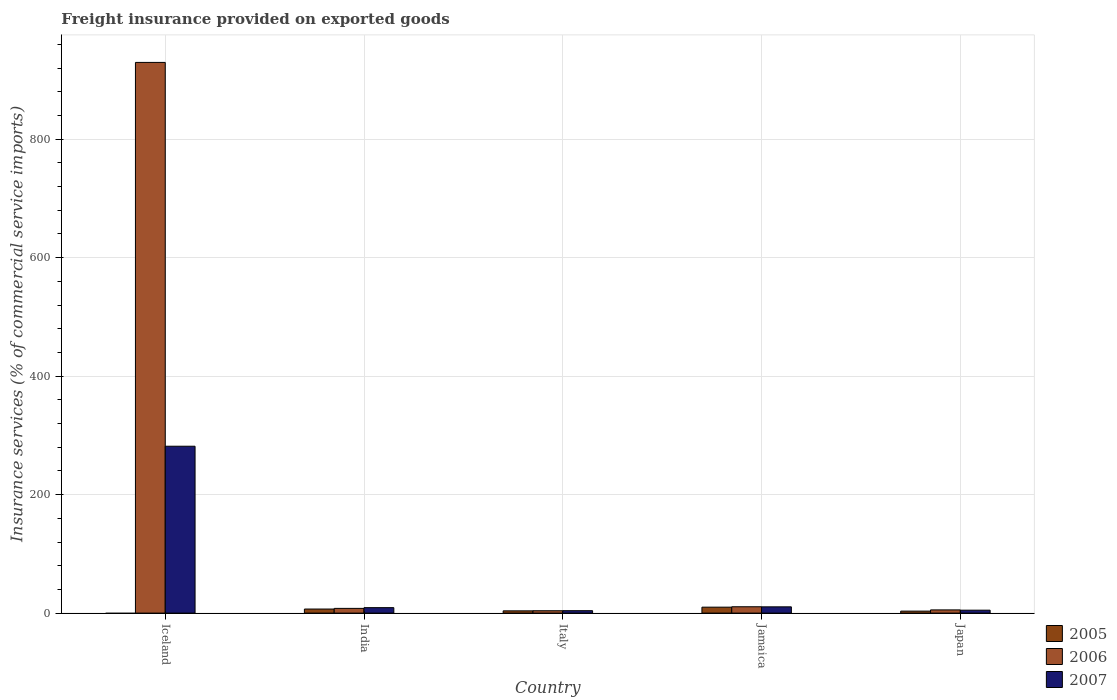How many different coloured bars are there?
Offer a terse response. 3. How many bars are there on the 1st tick from the left?
Offer a terse response. 2. In how many cases, is the number of bars for a given country not equal to the number of legend labels?
Provide a succinct answer. 1. What is the freight insurance provided on exported goods in 2005 in India?
Provide a succinct answer. 6.85. Across all countries, what is the maximum freight insurance provided on exported goods in 2006?
Make the answer very short. 929.6. Across all countries, what is the minimum freight insurance provided on exported goods in 2006?
Provide a short and direct response. 3.97. In which country was the freight insurance provided on exported goods in 2005 maximum?
Make the answer very short. Jamaica. What is the total freight insurance provided on exported goods in 2007 in the graph?
Your answer should be very brief. 310.44. What is the difference between the freight insurance provided on exported goods in 2007 in Italy and that in Japan?
Your answer should be compact. -0.85. What is the difference between the freight insurance provided on exported goods in 2006 in Jamaica and the freight insurance provided on exported goods in 2007 in Japan?
Offer a terse response. 5.79. What is the average freight insurance provided on exported goods in 2007 per country?
Offer a terse response. 62.09. What is the difference between the freight insurance provided on exported goods of/in 2007 and freight insurance provided on exported goods of/in 2005 in Japan?
Give a very brief answer. 1.59. What is the ratio of the freight insurance provided on exported goods in 2007 in India to that in Japan?
Your response must be concise. 1.87. Is the freight insurance provided on exported goods in 2006 in Iceland less than that in India?
Your answer should be compact. No. What is the difference between the highest and the second highest freight insurance provided on exported goods in 2007?
Provide a short and direct response. 271.12. What is the difference between the highest and the lowest freight insurance provided on exported goods in 2006?
Provide a succinct answer. 925.62. In how many countries, is the freight insurance provided on exported goods in 2006 greater than the average freight insurance provided on exported goods in 2006 taken over all countries?
Your answer should be very brief. 1. Is it the case that in every country, the sum of the freight insurance provided on exported goods in 2006 and freight insurance provided on exported goods in 2007 is greater than the freight insurance provided on exported goods in 2005?
Ensure brevity in your answer.  Yes. Are all the bars in the graph horizontal?
Make the answer very short. No. Are the values on the major ticks of Y-axis written in scientific E-notation?
Your answer should be very brief. No. What is the title of the graph?
Offer a terse response. Freight insurance provided on exported goods. Does "1989" appear as one of the legend labels in the graph?
Provide a short and direct response. No. What is the label or title of the X-axis?
Your answer should be compact. Country. What is the label or title of the Y-axis?
Offer a very short reply. Insurance services (% of commercial service imports). What is the Insurance services (% of commercial service imports) of 2005 in Iceland?
Ensure brevity in your answer.  0. What is the Insurance services (% of commercial service imports) in 2006 in Iceland?
Keep it short and to the point. 929.6. What is the Insurance services (% of commercial service imports) in 2007 in Iceland?
Your answer should be very brief. 281.68. What is the Insurance services (% of commercial service imports) of 2005 in India?
Provide a short and direct response. 6.85. What is the Insurance services (% of commercial service imports) of 2006 in India?
Offer a terse response. 7.96. What is the Insurance services (% of commercial service imports) in 2007 in India?
Your answer should be very brief. 9.21. What is the Insurance services (% of commercial service imports) in 2005 in Italy?
Your response must be concise. 3.79. What is the Insurance services (% of commercial service imports) in 2006 in Italy?
Your answer should be very brief. 3.97. What is the Insurance services (% of commercial service imports) in 2007 in Italy?
Provide a succinct answer. 4.07. What is the Insurance services (% of commercial service imports) in 2005 in Jamaica?
Provide a short and direct response. 10.03. What is the Insurance services (% of commercial service imports) in 2006 in Jamaica?
Provide a short and direct response. 10.71. What is the Insurance services (% of commercial service imports) of 2007 in Jamaica?
Your answer should be compact. 10.56. What is the Insurance services (% of commercial service imports) in 2005 in Japan?
Make the answer very short. 3.34. What is the Insurance services (% of commercial service imports) of 2006 in Japan?
Give a very brief answer. 5.41. What is the Insurance services (% of commercial service imports) of 2007 in Japan?
Offer a terse response. 4.92. Across all countries, what is the maximum Insurance services (% of commercial service imports) of 2005?
Keep it short and to the point. 10.03. Across all countries, what is the maximum Insurance services (% of commercial service imports) in 2006?
Your answer should be very brief. 929.6. Across all countries, what is the maximum Insurance services (% of commercial service imports) of 2007?
Offer a very short reply. 281.68. Across all countries, what is the minimum Insurance services (% of commercial service imports) in 2005?
Your answer should be very brief. 0. Across all countries, what is the minimum Insurance services (% of commercial service imports) in 2006?
Ensure brevity in your answer.  3.97. Across all countries, what is the minimum Insurance services (% of commercial service imports) of 2007?
Provide a short and direct response. 4.07. What is the total Insurance services (% of commercial service imports) in 2005 in the graph?
Offer a terse response. 24. What is the total Insurance services (% of commercial service imports) of 2006 in the graph?
Provide a succinct answer. 957.65. What is the total Insurance services (% of commercial service imports) in 2007 in the graph?
Keep it short and to the point. 310.44. What is the difference between the Insurance services (% of commercial service imports) in 2006 in Iceland and that in India?
Provide a short and direct response. 921.63. What is the difference between the Insurance services (% of commercial service imports) of 2007 in Iceland and that in India?
Your answer should be very brief. 272.46. What is the difference between the Insurance services (% of commercial service imports) of 2006 in Iceland and that in Italy?
Provide a succinct answer. 925.62. What is the difference between the Insurance services (% of commercial service imports) of 2007 in Iceland and that in Italy?
Provide a short and direct response. 277.6. What is the difference between the Insurance services (% of commercial service imports) of 2006 in Iceland and that in Jamaica?
Ensure brevity in your answer.  918.89. What is the difference between the Insurance services (% of commercial service imports) of 2007 in Iceland and that in Jamaica?
Offer a very short reply. 271.12. What is the difference between the Insurance services (% of commercial service imports) of 2006 in Iceland and that in Japan?
Keep it short and to the point. 924.19. What is the difference between the Insurance services (% of commercial service imports) in 2007 in Iceland and that in Japan?
Make the answer very short. 276.75. What is the difference between the Insurance services (% of commercial service imports) in 2005 in India and that in Italy?
Offer a terse response. 3.06. What is the difference between the Insurance services (% of commercial service imports) in 2006 in India and that in Italy?
Keep it short and to the point. 3.99. What is the difference between the Insurance services (% of commercial service imports) in 2007 in India and that in Italy?
Offer a terse response. 5.14. What is the difference between the Insurance services (% of commercial service imports) in 2005 in India and that in Jamaica?
Ensure brevity in your answer.  -3.18. What is the difference between the Insurance services (% of commercial service imports) in 2006 in India and that in Jamaica?
Provide a succinct answer. -2.75. What is the difference between the Insurance services (% of commercial service imports) in 2007 in India and that in Jamaica?
Keep it short and to the point. -1.35. What is the difference between the Insurance services (% of commercial service imports) of 2005 in India and that in Japan?
Your answer should be compact. 3.52. What is the difference between the Insurance services (% of commercial service imports) of 2006 in India and that in Japan?
Provide a short and direct response. 2.55. What is the difference between the Insurance services (% of commercial service imports) of 2007 in India and that in Japan?
Ensure brevity in your answer.  4.29. What is the difference between the Insurance services (% of commercial service imports) of 2005 in Italy and that in Jamaica?
Offer a very short reply. -6.24. What is the difference between the Insurance services (% of commercial service imports) of 2006 in Italy and that in Jamaica?
Offer a very short reply. -6.74. What is the difference between the Insurance services (% of commercial service imports) of 2007 in Italy and that in Jamaica?
Keep it short and to the point. -6.49. What is the difference between the Insurance services (% of commercial service imports) in 2005 in Italy and that in Japan?
Make the answer very short. 0.45. What is the difference between the Insurance services (% of commercial service imports) in 2006 in Italy and that in Japan?
Provide a succinct answer. -1.43. What is the difference between the Insurance services (% of commercial service imports) in 2007 in Italy and that in Japan?
Your response must be concise. -0.85. What is the difference between the Insurance services (% of commercial service imports) in 2005 in Jamaica and that in Japan?
Offer a very short reply. 6.69. What is the difference between the Insurance services (% of commercial service imports) in 2006 in Jamaica and that in Japan?
Give a very brief answer. 5.3. What is the difference between the Insurance services (% of commercial service imports) in 2007 in Jamaica and that in Japan?
Offer a very short reply. 5.64. What is the difference between the Insurance services (% of commercial service imports) in 2006 in Iceland and the Insurance services (% of commercial service imports) in 2007 in India?
Provide a succinct answer. 920.38. What is the difference between the Insurance services (% of commercial service imports) in 2006 in Iceland and the Insurance services (% of commercial service imports) in 2007 in Italy?
Your answer should be very brief. 925.52. What is the difference between the Insurance services (% of commercial service imports) of 2006 in Iceland and the Insurance services (% of commercial service imports) of 2007 in Jamaica?
Keep it short and to the point. 919.04. What is the difference between the Insurance services (% of commercial service imports) in 2006 in Iceland and the Insurance services (% of commercial service imports) in 2007 in Japan?
Give a very brief answer. 924.67. What is the difference between the Insurance services (% of commercial service imports) of 2005 in India and the Insurance services (% of commercial service imports) of 2006 in Italy?
Your answer should be very brief. 2.88. What is the difference between the Insurance services (% of commercial service imports) in 2005 in India and the Insurance services (% of commercial service imports) in 2007 in Italy?
Make the answer very short. 2.78. What is the difference between the Insurance services (% of commercial service imports) of 2006 in India and the Insurance services (% of commercial service imports) of 2007 in Italy?
Your answer should be very brief. 3.89. What is the difference between the Insurance services (% of commercial service imports) in 2005 in India and the Insurance services (% of commercial service imports) in 2006 in Jamaica?
Provide a short and direct response. -3.86. What is the difference between the Insurance services (% of commercial service imports) in 2005 in India and the Insurance services (% of commercial service imports) in 2007 in Jamaica?
Ensure brevity in your answer.  -3.71. What is the difference between the Insurance services (% of commercial service imports) in 2006 in India and the Insurance services (% of commercial service imports) in 2007 in Jamaica?
Ensure brevity in your answer.  -2.6. What is the difference between the Insurance services (% of commercial service imports) in 2005 in India and the Insurance services (% of commercial service imports) in 2006 in Japan?
Offer a terse response. 1.44. What is the difference between the Insurance services (% of commercial service imports) in 2005 in India and the Insurance services (% of commercial service imports) in 2007 in Japan?
Keep it short and to the point. 1.93. What is the difference between the Insurance services (% of commercial service imports) of 2006 in India and the Insurance services (% of commercial service imports) of 2007 in Japan?
Ensure brevity in your answer.  3.04. What is the difference between the Insurance services (% of commercial service imports) of 2005 in Italy and the Insurance services (% of commercial service imports) of 2006 in Jamaica?
Give a very brief answer. -6.92. What is the difference between the Insurance services (% of commercial service imports) of 2005 in Italy and the Insurance services (% of commercial service imports) of 2007 in Jamaica?
Give a very brief answer. -6.77. What is the difference between the Insurance services (% of commercial service imports) of 2006 in Italy and the Insurance services (% of commercial service imports) of 2007 in Jamaica?
Provide a short and direct response. -6.59. What is the difference between the Insurance services (% of commercial service imports) in 2005 in Italy and the Insurance services (% of commercial service imports) in 2006 in Japan?
Offer a terse response. -1.62. What is the difference between the Insurance services (% of commercial service imports) of 2005 in Italy and the Insurance services (% of commercial service imports) of 2007 in Japan?
Offer a very short reply. -1.14. What is the difference between the Insurance services (% of commercial service imports) of 2006 in Italy and the Insurance services (% of commercial service imports) of 2007 in Japan?
Offer a very short reply. -0.95. What is the difference between the Insurance services (% of commercial service imports) in 2005 in Jamaica and the Insurance services (% of commercial service imports) in 2006 in Japan?
Your answer should be very brief. 4.62. What is the difference between the Insurance services (% of commercial service imports) of 2005 in Jamaica and the Insurance services (% of commercial service imports) of 2007 in Japan?
Give a very brief answer. 5.1. What is the difference between the Insurance services (% of commercial service imports) in 2006 in Jamaica and the Insurance services (% of commercial service imports) in 2007 in Japan?
Ensure brevity in your answer.  5.79. What is the average Insurance services (% of commercial service imports) in 2005 per country?
Provide a short and direct response. 4.8. What is the average Insurance services (% of commercial service imports) of 2006 per country?
Keep it short and to the point. 191.53. What is the average Insurance services (% of commercial service imports) in 2007 per country?
Your answer should be very brief. 62.09. What is the difference between the Insurance services (% of commercial service imports) of 2006 and Insurance services (% of commercial service imports) of 2007 in Iceland?
Keep it short and to the point. 647.92. What is the difference between the Insurance services (% of commercial service imports) in 2005 and Insurance services (% of commercial service imports) in 2006 in India?
Your response must be concise. -1.11. What is the difference between the Insurance services (% of commercial service imports) of 2005 and Insurance services (% of commercial service imports) of 2007 in India?
Your answer should be very brief. -2.36. What is the difference between the Insurance services (% of commercial service imports) of 2006 and Insurance services (% of commercial service imports) of 2007 in India?
Offer a terse response. -1.25. What is the difference between the Insurance services (% of commercial service imports) of 2005 and Insurance services (% of commercial service imports) of 2006 in Italy?
Provide a short and direct response. -0.19. What is the difference between the Insurance services (% of commercial service imports) in 2005 and Insurance services (% of commercial service imports) in 2007 in Italy?
Make the answer very short. -0.29. What is the difference between the Insurance services (% of commercial service imports) in 2006 and Insurance services (% of commercial service imports) in 2007 in Italy?
Provide a succinct answer. -0.1. What is the difference between the Insurance services (% of commercial service imports) of 2005 and Insurance services (% of commercial service imports) of 2006 in Jamaica?
Provide a succinct answer. -0.68. What is the difference between the Insurance services (% of commercial service imports) in 2005 and Insurance services (% of commercial service imports) in 2007 in Jamaica?
Offer a very short reply. -0.53. What is the difference between the Insurance services (% of commercial service imports) of 2006 and Insurance services (% of commercial service imports) of 2007 in Jamaica?
Ensure brevity in your answer.  0.15. What is the difference between the Insurance services (% of commercial service imports) of 2005 and Insurance services (% of commercial service imports) of 2006 in Japan?
Provide a succinct answer. -2.07. What is the difference between the Insurance services (% of commercial service imports) in 2005 and Insurance services (% of commercial service imports) in 2007 in Japan?
Your response must be concise. -1.59. What is the difference between the Insurance services (% of commercial service imports) of 2006 and Insurance services (% of commercial service imports) of 2007 in Japan?
Keep it short and to the point. 0.49. What is the ratio of the Insurance services (% of commercial service imports) in 2006 in Iceland to that in India?
Your answer should be compact. 116.76. What is the ratio of the Insurance services (% of commercial service imports) in 2007 in Iceland to that in India?
Keep it short and to the point. 30.58. What is the ratio of the Insurance services (% of commercial service imports) of 2006 in Iceland to that in Italy?
Ensure brevity in your answer.  233.89. What is the ratio of the Insurance services (% of commercial service imports) of 2007 in Iceland to that in Italy?
Offer a very short reply. 69.15. What is the ratio of the Insurance services (% of commercial service imports) in 2006 in Iceland to that in Jamaica?
Your answer should be very brief. 86.79. What is the ratio of the Insurance services (% of commercial service imports) of 2007 in Iceland to that in Jamaica?
Ensure brevity in your answer.  26.67. What is the ratio of the Insurance services (% of commercial service imports) of 2006 in Iceland to that in Japan?
Keep it short and to the point. 171.85. What is the ratio of the Insurance services (% of commercial service imports) of 2007 in Iceland to that in Japan?
Offer a very short reply. 57.22. What is the ratio of the Insurance services (% of commercial service imports) of 2005 in India to that in Italy?
Your answer should be very brief. 1.81. What is the ratio of the Insurance services (% of commercial service imports) in 2006 in India to that in Italy?
Your answer should be very brief. 2. What is the ratio of the Insurance services (% of commercial service imports) of 2007 in India to that in Italy?
Make the answer very short. 2.26. What is the ratio of the Insurance services (% of commercial service imports) of 2005 in India to that in Jamaica?
Make the answer very short. 0.68. What is the ratio of the Insurance services (% of commercial service imports) in 2006 in India to that in Jamaica?
Give a very brief answer. 0.74. What is the ratio of the Insurance services (% of commercial service imports) of 2007 in India to that in Jamaica?
Make the answer very short. 0.87. What is the ratio of the Insurance services (% of commercial service imports) of 2005 in India to that in Japan?
Your answer should be compact. 2.05. What is the ratio of the Insurance services (% of commercial service imports) of 2006 in India to that in Japan?
Your answer should be compact. 1.47. What is the ratio of the Insurance services (% of commercial service imports) of 2007 in India to that in Japan?
Your answer should be very brief. 1.87. What is the ratio of the Insurance services (% of commercial service imports) of 2005 in Italy to that in Jamaica?
Offer a terse response. 0.38. What is the ratio of the Insurance services (% of commercial service imports) of 2006 in Italy to that in Jamaica?
Offer a terse response. 0.37. What is the ratio of the Insurance services (% of commercial service imports) of 2007 in Italy to that in Jamaica?
Your answer should be very brief. 0.39. What is the ratio of the Insurance services (% of commercial service imports) of 2005 in Italy to that in Japan?
Make the answer very short. 1.14. What is the ratio of the Insurance services (% of commercial service imports) in 2006 in Italy to that in Japan?
Provide a succinct answer. 0.73. What is the ratio of the Insurance services (% of commercial service imports) of 2007 in Italy to that in Japan?
Offer a very short reply. 0.83. What is the ratio of the Insurance services (% of commercial service imports) in 2005 in Jamaica to that in Japan?
Your answer should be compact. 3.01. What is the ratio of the Insurance services (% of commercial service imports) of 2006 in Jamaica to that in Japan?
Ensure brevity in your answer.  1.98. What is the ratio of the Insurance services (% of commercial service imports) of 2007 in Jamaica to that in Japan?
Provide a short and direct response. 2.15. What is the difference between the highest and the second highest Insurance services (% of commercial service imports) of 2005?
Your answer should be compact. 3.18. What is the difference between the highest and the second highest Insurance services (% of commercial service imports) in 2006?
Offer a very short reply. 918.89. What is the difference between the highest and the second highest Insurance services (% of commercial service imports) in 2007?
Your answer should be compact. 271.12. What is the difference between the highest and the lowest Insurance services (% of commercial service imports) in 2005?
Give a very brief answer. 10.03. What is the difference between the highest and the lowest Insurance services (% of commercial service imports) in 2006?
Provide a succinct answer. 925.62. What is the difference between the highest and the lowest Insurance services (% of commercial service imports) of 2007?
Your answer should be very brief. 277.6. 